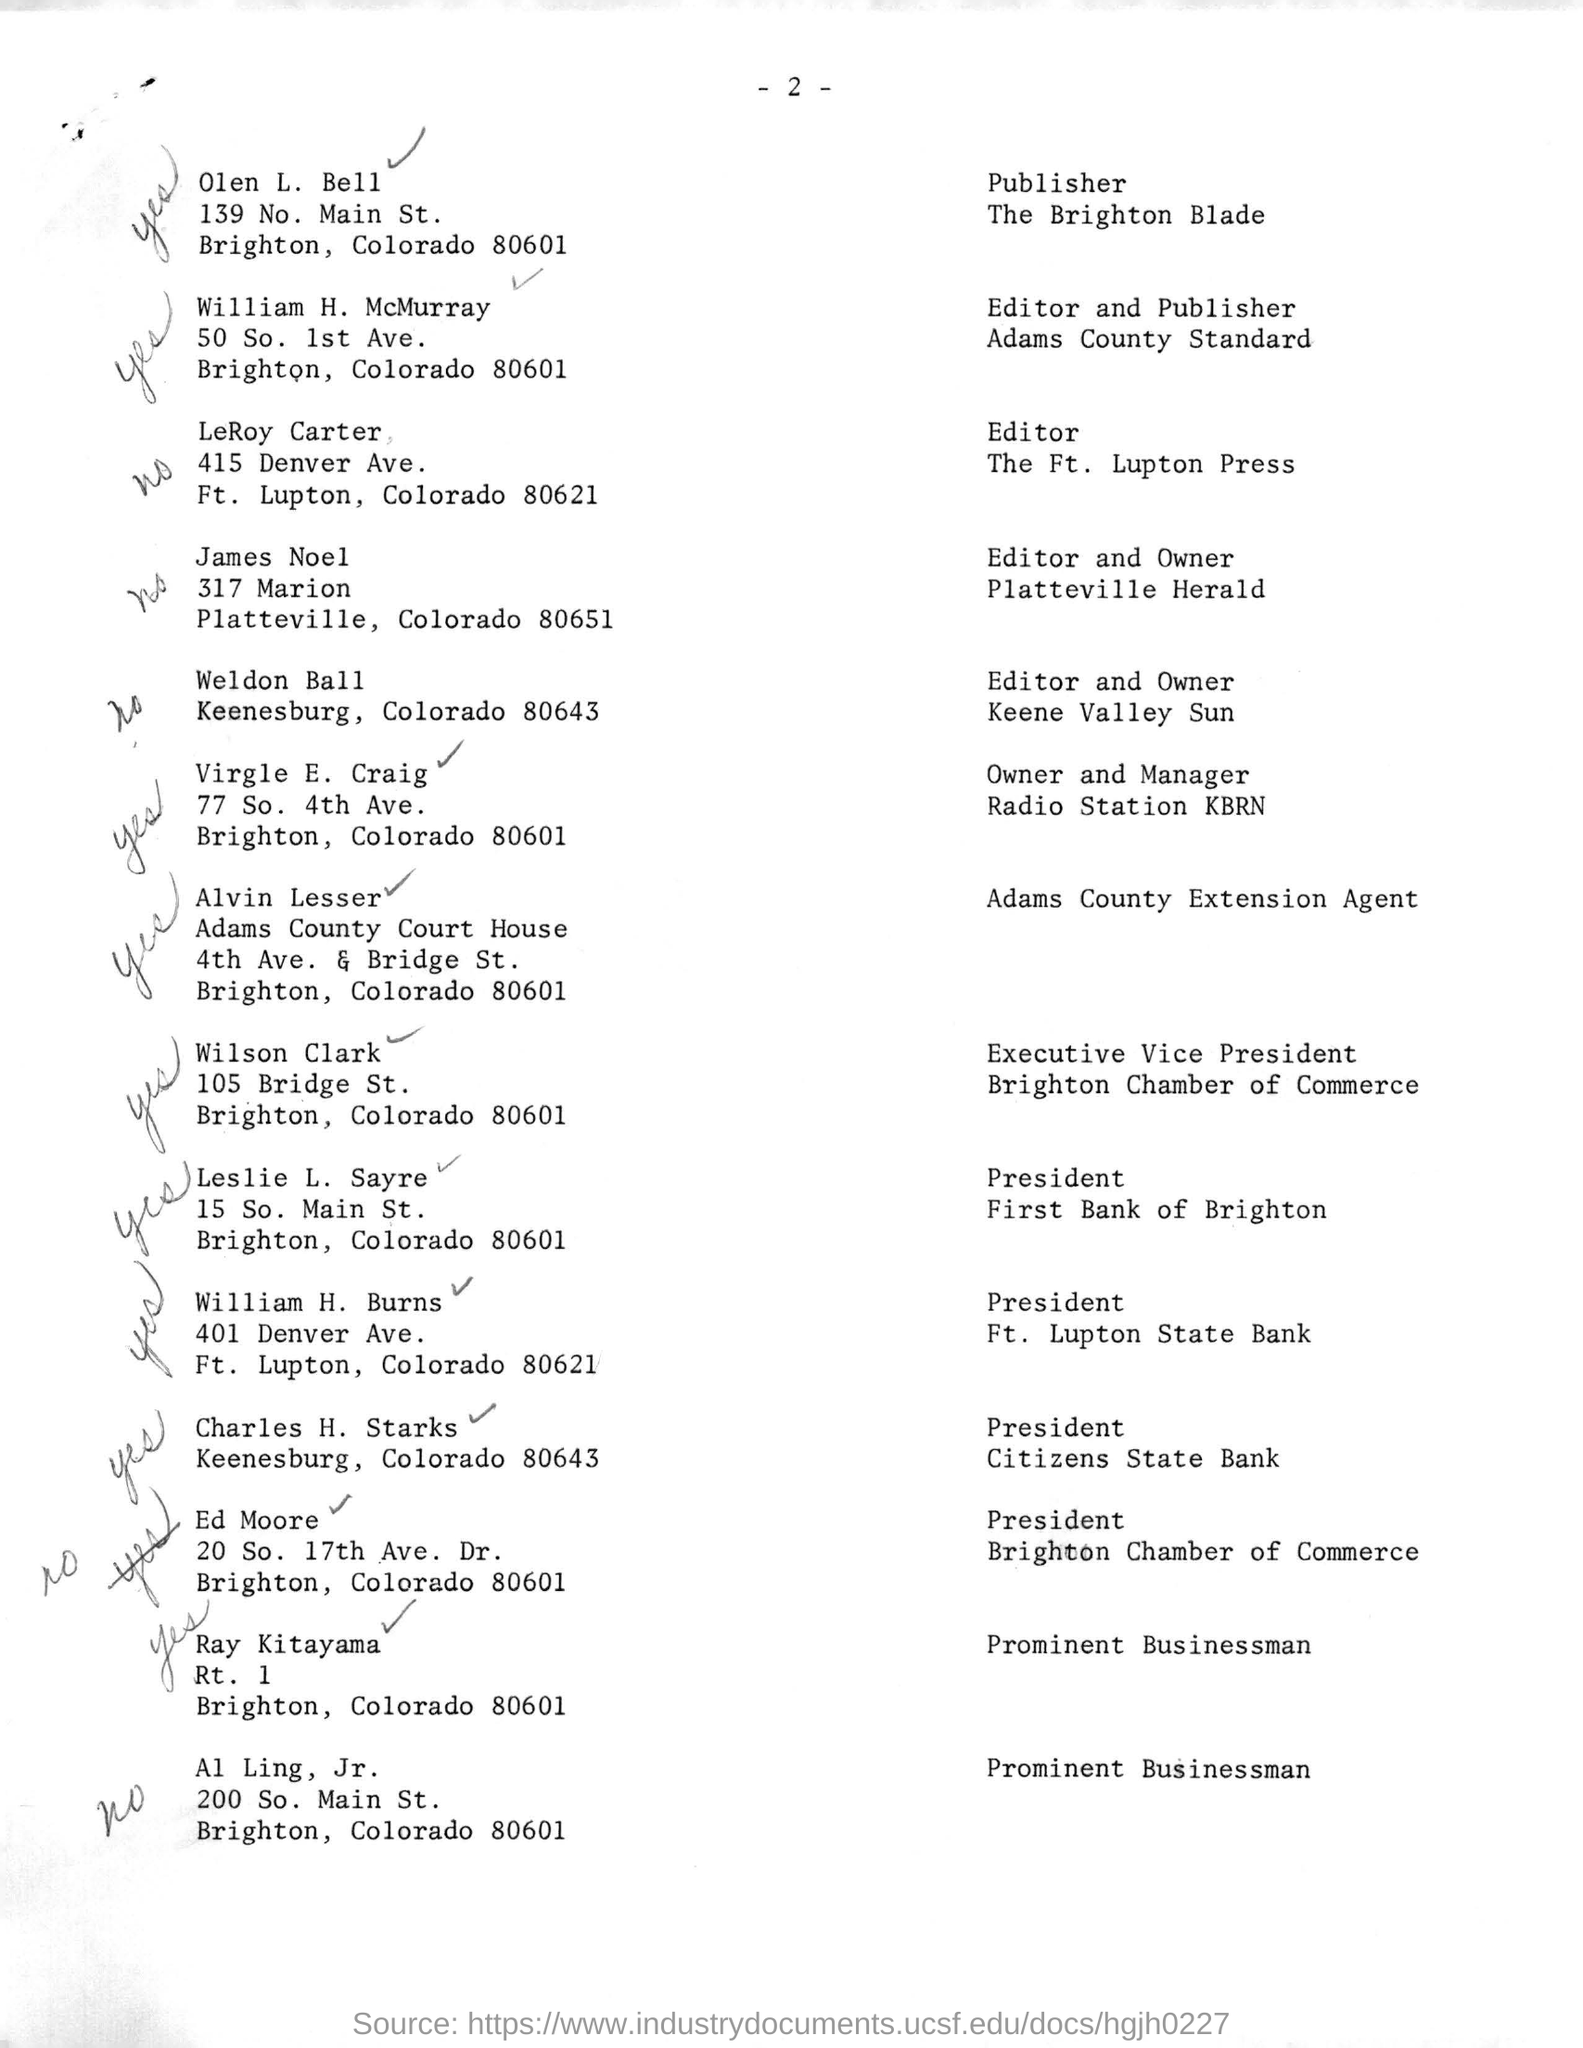What is the page no mentioned in this document?
Provide a succinct answer. - 2 -. 